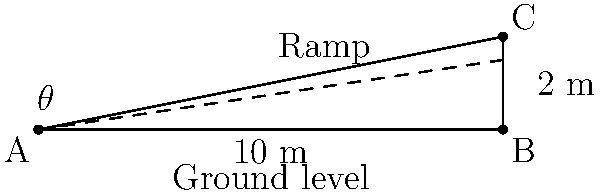You're planning to install a wheelchair ramp at your local community center to improve accessibility. The ramp needs to rise 2 meters over a horizontal distance of 10 meters. What is the angle of elevation ($\theta$) of the ramp to the nearest degree? (Note: This angle is important for ensuring the ramp is not too steep for wheelchair users.) Let's approach this step-by-step:

1) We can treat this as a right-angled triangle problem. The ramp forms the hypotenuse of the triangle.

2) We know:
   - The vertical rise (opposite side) is 2 meters
   - The horizontal distance (adjacent side) is 10 meters

3) To find the angle $\theta$, we can use the tangent function:

   $\tan(\theta) = \frac{\text{opposite}}{\text{adjacent}} = \frac{\text{rise}}{\text{run}}$

4) Plugging in our values:

   $\tan(\theta) = \frac{2}{10} = 0.2$

5) To find $\theta$, we need to use the inverse tangent (arctan or $\tan^{-1}$):

   $\theta = \tan^{-1}(0.2)$

6) Using a calculator (or calculator function):

   $\theta \approx 11.31$ degrees

7) Rounding to the nearest degree:

   $\theta \approx 11$ degrees

This angle is within the recommended range for wheelchair ramps (usually between 4.8° and 8.3° maximum), but it's slightly steeper than ideal. In practice, a longer ramp with a gentler slope might be preferable for easier access.
Answer: 11° 